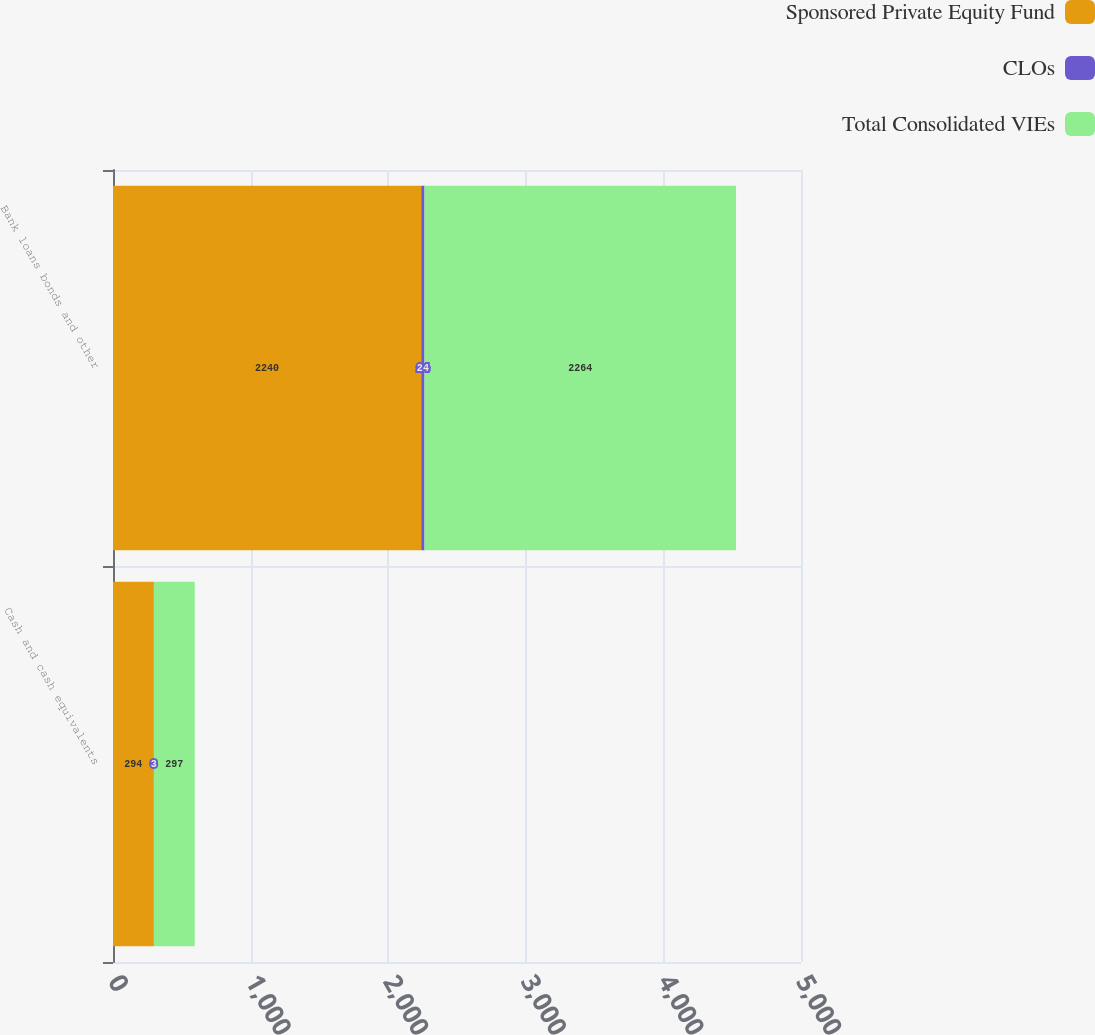Convert chart. <chart><loc_0><loc_0><loc_500><loc_500><stacked_bar_chart><ecel><fcel>Cash and cash equivalents<fcel>Bank loans bonds and other<nl><fcel>Sponsored Private Equity Fund<fcel>294<fcel>2240<nl><fcel>CLOs<fcel>3<fcel>24<nl><fcel>Total Consolidated VIEs<fcel>297<fcel>2264<nl></chart> 